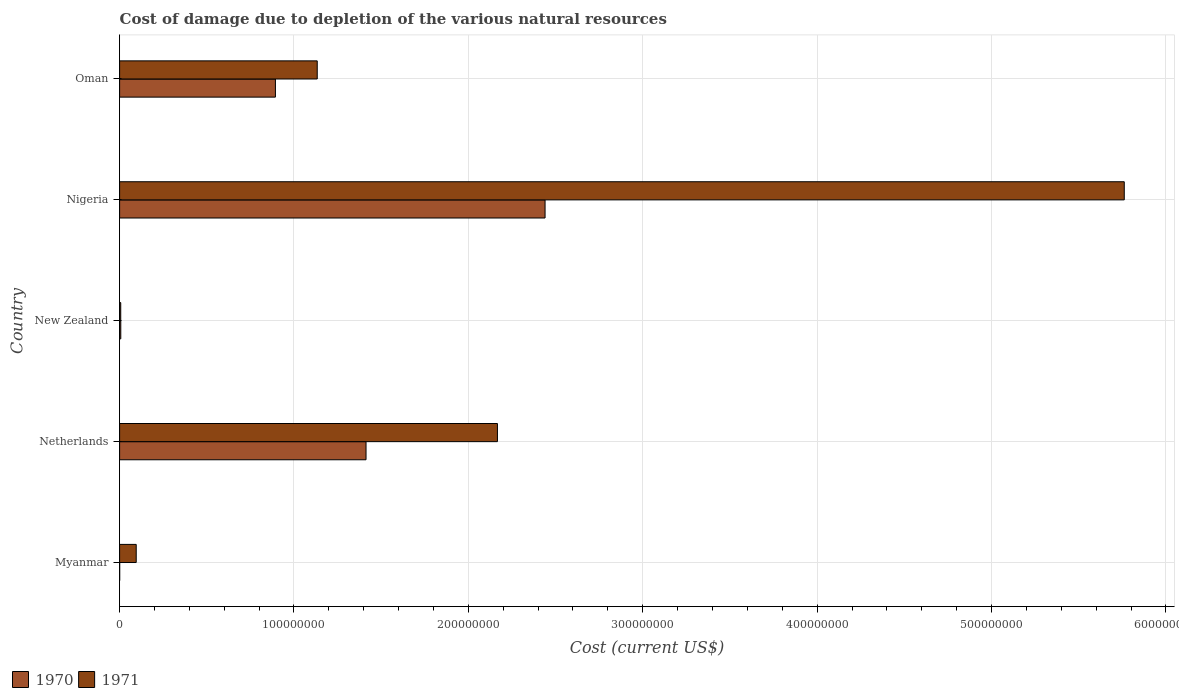How many different coloured bars are there?
Your answer should be very brief. 2. How many groups of bars are there?
Offer a very short reply. 5. Are the number of bars per tick equal to the number of legend labels?
Provide a succinct answer. Yes. How many bars are there on the 3rd tick from the top?
Ensure brevity in your answer.  2. What is the label of the 3rd group of bars from the top?
Your response must be concise. New Zealand. What is the cost of damage caused due to the depletion of various natural resources in 1970 in Netherlands?
Make the answer very short. 1.41e+08. Across all countries, what is the maximum cost of damage caused due to the depletion of various natural resources in 1970?
Give a very brief answer. 2.44e+08. Across all countries, what is the minimum cost of damage caused due to the depletion of various natural resources in 1971?
Your response must be concise. 6.53e+05. In which country was the cost of damage caused due to the depletion of various natural resources in 1970 maximum?
Provide a succinct answer. Nigeria. In which country was the cost of damage caused due to the depletion of various natural resources in 1970 minimum?
Ensure brevity in your answer.  Myanmar. What is the total cost of damage caused due to the depletion of various natural resources in 1971 in the graph?
Offer a very short reply. 9.16e+08. What is the difference between the cost of damage caused due to the depletion of various natural resources in 1971 in Netherlands and that in New Zealand?
Your answer should be very brief. 2.16e+08. What is the difference between the cost of damage caused due to the depletion of various natural resources in 1971 in New Zealand and the cost of damage caused due to the depletion of various natural resources in 1970 in Myanmar?
Provide a short and direct response. 6.13e+05. What is the average cost of damage caused due to the depletion of various natural resources in 1971 per country?
Provide a short and direct response. 1.83e+08. What is the difference between the cost of damage caused due to the depletion of various natural resources in 1970 and cost of damage caused due to the depletion of various natural resources in 1971 in New Zealand?
Your response must be concise. 2.77e+04. In how many countries, is the cost of damage caused due to the depletion of various natural resources in 1971 greater than 400000000 US$?
Your answer should be very brief. 1. What is the ratio of the cost of damage caused due to the depletion of various natural resources in 1970 in Netherlands to that in Oman?
Offer a very short reply. 1.58. Is the cost of damage caused due to the depletion of various natural resources in 1971 in New Zealand less than that in Oman?
Provide a succinct answer. Yes. What is the difference between the highest and the second highest cost of damage caused due to the depletion of various natural resources in 1970?
Make the answer very short. 1.03e+08. What is the difference between the highest and the lowest cost of damage caused due to the depletion of various natural resources in 1970?
Offer a terse response. 2.44e+08. How many bars are there?
Offer a terse response. 10. Are all the bars in the graph horizontal?
Provide a succinct answer. Yes. What is the difference between two consecutive major ticks on the X-axis?
Provide a short and direct response. 1.00e+08. Does the graph contain any zero values?
Make the answer very short. No. Does the graph contain grids?
Your answer should be compact. Yes. How many legend labels are there?
Keep it short and to the point. 2. How are the legend labels stacked?
Give a very brief answer. Horizontal. What is the title of the graph?
Ensure brevity in your answer.  Cost of damage due to depletion of the various natural resources. Does "1967" appear as one of the legend labels in the graph?
Give a very brief answer. No. What is the label or title of the X-axis?
Your answer should be compact. Cost (current US$). What is the label or title of the Y-axis?
Offer a very short reply. Country. What is the Cost (current US$) in 1970 in Myanmar?
Give a very brief answer. 3.91e+04. What is the Cost (current US$) in 1971 in Myanmar?
Ensure brevity in your answer.  9.53e+06. What is the Cost (current US$) in 1970 in Netherlands?
Make the answer very short. 1.41e+08. What is the Cost (current US$) of 1971 in Netherlands?
Your answer should be compact. 2.17e+08. What is the Cost (current US$) of 1970 in New Zealand?
Offer a very short reply. 6.80e+05. What is the Cost (current US$) of 1971 in New Zealand?
Your response must be concise. 6.53e+05. What is the Cost (current US$) of 1970 in Nigeria?
Provide a succinct answer. 2.44e+08. What is the Cost (current US$) of 1971 in Nigeria?
Provide a succinct answer. 5.76e+08. What is the Cost (current US$) of 1970 in Oman?
Ensure brevity in your answer.  8.94e+07. What is the Cost (current US$) of 1971 in Oman?
Ensure brevity in your answer.  1.13e+08. Across all countries, what is the maximum Cost (current US$) of 1970?
Offer a terse response. 2.44e+08. Across all countries, what is the maximum Cost (current US$) in 1971?
Ensure brevity in your answer.  5.76e+08. Across all countries, what is the minimum Cost (current US$) of 1970?
Provide a succinct answer. 3.91e+04. Across all countries, what is the minimum Cost (current US$) in 1971?
Make the answer very short. 6.53e+05. What is the total Cost (current US$) of 1970 in the graph?
Provide a succinct answer. 4.75e+08. What is the total Cost (current US$) in 1971 in the graph?
Your response must be concise. 9.16e+08. What is the difference between the Cost (current US$) in 1970 in Myanmar and that in Netherlands?
Offer a very short reply. -1.41e+08. What is the difference between the Cost (current US$) in 1971 in Myanmar and that in Netherlands?
Your response must be concise. -2.07e+08. What is the difference between the Cost (current US$) in 1970 in Myanmar and that in New Zealand?
Offer a very short reply. -6.41e+05. What is the difference between the Cost (current US$) of 1971 in Myanmar and that in New Zealand?
Keep it short and to the point. 8.87e+06. What is the difference between the Cost (current US$) of 1970 in Myanmar and that in Nigeria?
Give a very brief answer. -2.44e+08. What is the difference between the Cost (current US$) of 1971 in Myanmar and that in Nigeria?
Offer a terse response. -5.67e+08. What is the difference between the Cost (current US$) in 1970 in Myanmar and that in Oman?
Offer a very short reply. -8.93e+07. What is the difference between the Cost (current US$) of 1971 in Myanmar and that in Oman?
Offer a very short reply. -1.04e+08. What is the difference between the Cost (current US$) of 1970 in Netherlands and that in New Zealand?
Your response must be concise. 1.41e+08. What is the difference between the Cost (current US$) of 1971 in Netherlands and that in New Zealand?
Your answer should be very brief. 2.16e+08. What is the difference between the Cost (current US$) of 1970 in Netherlands and that in Nigeria?
Make the answer very short. -1.03e+08. What is the difference between the Cost (current US$) in 1971 in Netherlands and that in Nigeria?
Your response must be concise. -3.59e+08. What is the difference between the Cost (current US$) of 1970 in Netherlands and that in Oman?
Ensure brevity in your answer.  5.20e+07. What is the difference between the Cost (current US$) of 1971 in Netherlands and that in Oman?
Your answer should be very brief. 1.03e+08. What is the difference between the Cost (current US$) of 1970 in New Zealand and that in Nigeria?
Your answer should be very brief. -2.43e+08. What is the difference between the Cost (current US$) in 1971 in New Zealand and that in Nigeria?
Provide a succinct answer. -5.75e+08. What is the difference between the Cost (current US$) of 1970 in New Zealand and that in Oman?
Offer a very short reply. -8.87e+07. What is the difference between the Cost (current US$) of 1971 in New Zealand and that in Oman?
Give a very brief answer. -1.13e+08. What is the difference between the Cost (current US$) of 1970 in Nigeria and that in Oman?
Keep it short and to the point. 1.55e+08. What is the difference between the Cost (current US$) of 1971 in Nigeria and that in Oman?
Your answer should be compact. 4.63e+08. What is the difference between the Cost (current US$) of 1970 in Myanmar and the Cost (current US$) of 1971 in Netherlands?
Provide a succinct answer. -2.17e+08. What is the difference between the Cost (current US$) in 1970 in Myanmar and the Cost (current US$) in 1971 in New Zealand?
Ensure brevity in your answer.  -6.13e+05. What is the difference between the Cost (current US$) of 1970 in Myanmar and the Cost (current US$) of 1971 in Nigeria?
Offer a terse response. -5.76e+08. What is the difference between the Cost (current US$) of 1970 in Myanmar and the Cost (current US$) of 1971 in Oman?
Provide a short and direct response. -1.13e+08. What is the difference between the Cost (current US$) in 1970 in Netherlands and the Cost (current US$) in 1971 in New Zealand?
Offer a very short reply. 1.41e+08. What is the difference between the Cost (current US$) of 1970 in Netherlands and the Cost (current US$) of 1971 in Nigeria?
Your response must be concise. -4.35e+08. What is the difference between the Cost (current US$) of 1970 in Netherlands and the Cost (current US$) of 1971 in Oman?
Your response must be concise. 2.80e+07. What is the difference between the Cost (current US$) of 1970 in New Zealand and the Cost (current US$) of 1971 in Nigeria?
Your answer should be compact. -5.75e+08. What is the difference between the Cost (current US$) in 1970 in New Zealand and the Cost (current US$) in 1971 in Oman?
Offer a terse response. -1.13e+08. What is the difference between the Cost (current US$) of 1970 in Nigeria and the Cost (current US$) of 1971 in Oman?
Keep it short and to the point. 1.31e+08. What is the average Cost (current US$) in 1970 per country?
Provide a succinct answer. 9.51e+07. What is the average Cost (current US$) in 1971 per country?
Give a very brief answer. 1.83e+08. What is the difference between the Cost (current US$) of 1970 and Cost (current US$) of 1971 in Myanmar?
Your answer should be very brief. -9.49e+06. What is the difference between the Cost (current US$) in 1970 and Cost (current US$) in 1971 in Netherlands?
Make the answer very short. -7.54e+07. What is the difference between the Cost (current US$) in 1970 and Cost (current US$) in 1971 in New Zealand?
Ensure brevity in your answer.  2.77e+04. What is the difference between the Cost (current US$) in 1970 and Cost (current US$) in 1971 in Nigeria?
Your answer should be compact. -3.32e+08. What is the difference between the Cost (current US$) of 1970 and Cost (current US$) of 1971 in Oman?
Your response must be concise. -2.40e+07. What is the ratio of the Cost (current US$) of 1970 in Myanmar to that in Netherlands?
Your answer should be compact. 0. What is the ratio of the Cost (current US$) of 1971 in Myanmar to that in Netherlands?
Give a very brief answer. 0.04. What is the ratio of the Cost (current US$) in 1970 in Myanmar to that in New Zealand?
Offer a very short reply. 0.06. What is the ratio of the Cost (current US$) of 1971 in Myanmar to that in New Zealand?
Provide a short and direct response. 14.6. What is the ratio of the Cost (current US$) in 1970 in Myanmar to that in Nigeria?
Your response must be concise. 0. What is the ratio of the Cost (current US$) of 1971 in Myanmar to that in Nigeria?
Provide a short and direct response. 0.02. What is the ratio of the Cost (current US$) in 1971 in Myanmar to that in Oman?
Give a very brief answer. 0.08. What is the ratio of the Cost (current US$) in 1970 in Netherlands to that in New Zealand?
Offer a terse response. 207.74. What is the ratio of the Cost (current US$) in 1971 in Netherlands to that in New Zealand?
Make the answer very short. 332.04. What is the ratio of the Cost (current US$) of 1970 in Netherlands to that in Nigeria?
Provide a succinct answer. 0.58. What is the ratio of the Cost (current US$) of 1971 in Netherlands to that in Nigeria?
Your response must be concise. 0.38. What is the ratio of the Cost (current US$) in 1970 in Netherlands to that in Oman?
Your response must be concise. 1.58. What is the ratio of the Cost (current US$) of 1971 in Netherlands to that in Oman?
Your answer should be very brief. 1.91. What is the ratio of the Cost (current US$) in 1970 in New Zealand to that in Nigeria?
Your answer should be compact. 0. What is the ratio of the Cost (current US$) in 1971 in New Zealand to that in Nigeria?
Ensure brevity in your answer.  0. What is the ratio of the Cost (current US$) of 1970 in New Zealand to that in Oman?
Give a very brief answer. 0.01. What is the ratio of the Cost (current US$) in 1971 in New Zealand to that in Oman?
Offer a very short reply. 0.01. What is the ratio of the Cost (current US$) of 1970 in Nigeria to that in Oman?
Offer a very short reply. 2.73. What is the ratio of the Cost (current US$) in 1971 in Nigeria to that in Oman?
Offer a terse response. 5.08. What is the difference between the highest and the second highest Cost (current US$) in 1970?
Provide a succinct answer. 1.03e+08. What is the difference between the highest and the second highest Cost (current US$) in 1971?
Keep it short and to the point. 3.59e+08. What is the difference between the highest and the lowest Cost (current US$) in 1970?
Keep it short and to the point. 2.44e+08. What is the difference between the highest and the lowest Cost (current US$) in 1971?
Provide a succinct answer. 5.75e+08. 